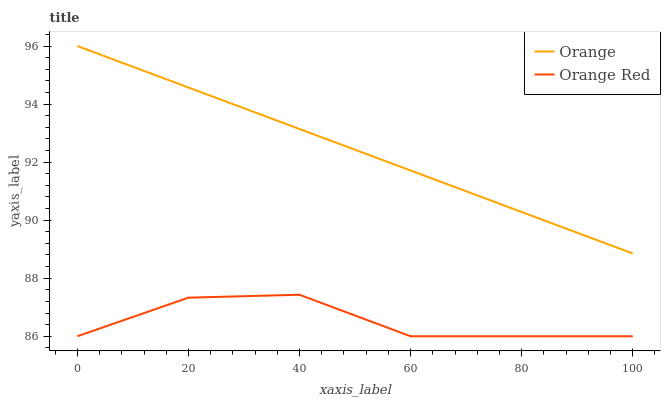Does Orange Red have the minimum area under the curve?
Answer yes or no. Yes. Does Orange have the maximum area under the curve?
Answer yes or no. Yes. Does Orange Red have the maximum area under the curve?
Answer yes or no. No. Is Orange the smoothest?
Answer yes or no. Yes. Is Orange Red the roughest?
Answer yes or no. Yes. Is Orange Red the smoothest?
Answer yes or no. No. Does Orange Red have the lowest value?
Answer yes or no. Yes. Does Orange have the highest value?
Answer yes or no. Yes. Does Orange Red have the highest value?
Answer yes or no. No. Is Orange Red less than Orange?
Answer yes or no. Yes. Is Orange greater than Orange Red?
Answer yes or no. Yes. Does Orange Red intersect Orange?
Answer yes or no. No. 